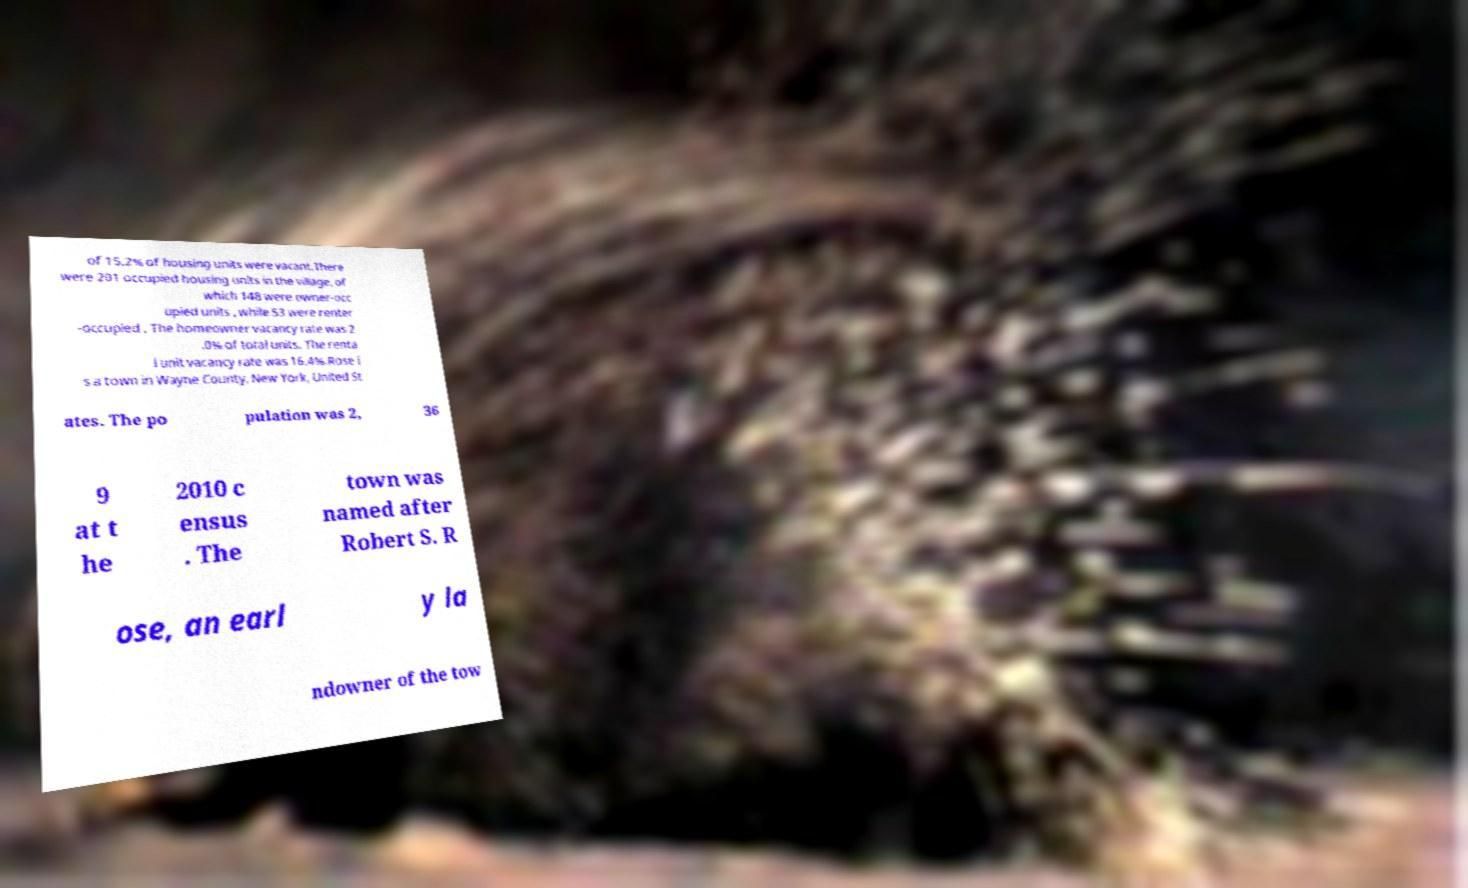What messages or text are displayed in this image? I need them in a readable, typed format. of 15.2% of housing units were vacant.There were 201 occupied housing units in the village, of which 148 were owner-occ upied units , while 53 were renter -occupied . The homeowner vacancy rate was 2 .0% of total units. The renta l unit vacancy rate was 16.4%.Rose i s a town in Wayne County, New York, United St ates. The po pulation was 2, 36 9 at t he 2010 c ensus . The town was named after Robert S. R ose, an earl y la ndowner of the tow 